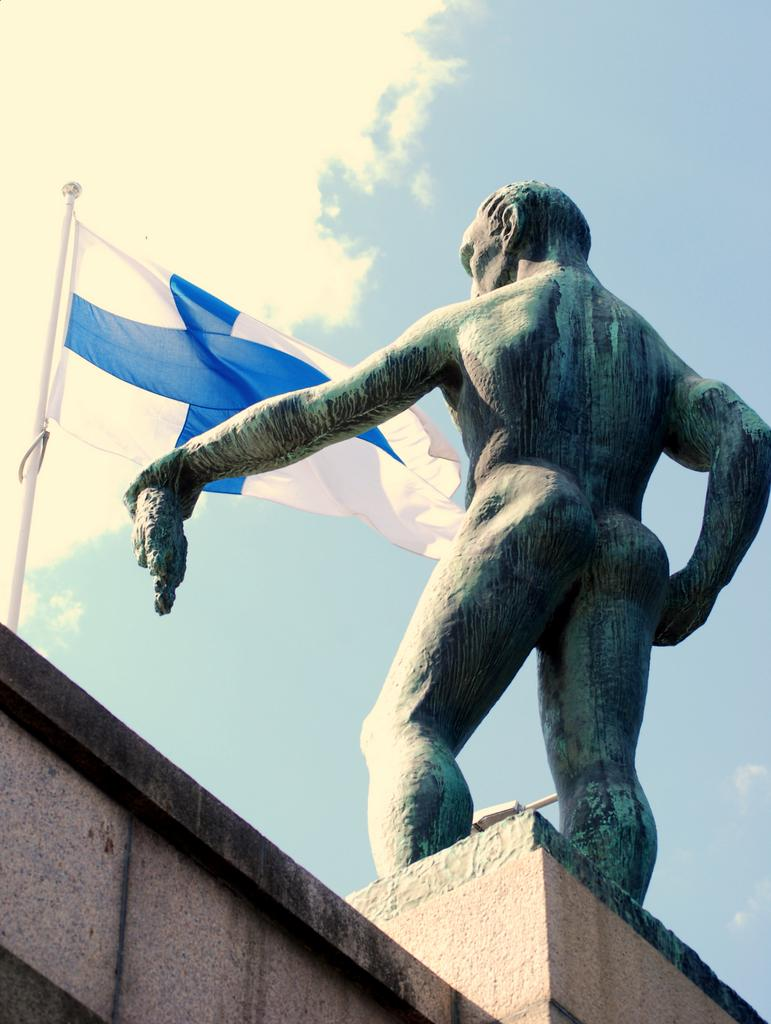What is the main subject of the image? There is a stone statue of a man in the image. Where is the statue placed? The statue is placed on a brown wall. What can be seen in the background of the image? There is a white and blue color flag in the background of the image. What type of income does the man in the statue earn? The man in the statue is not a real person, so there is no income associated with him. 